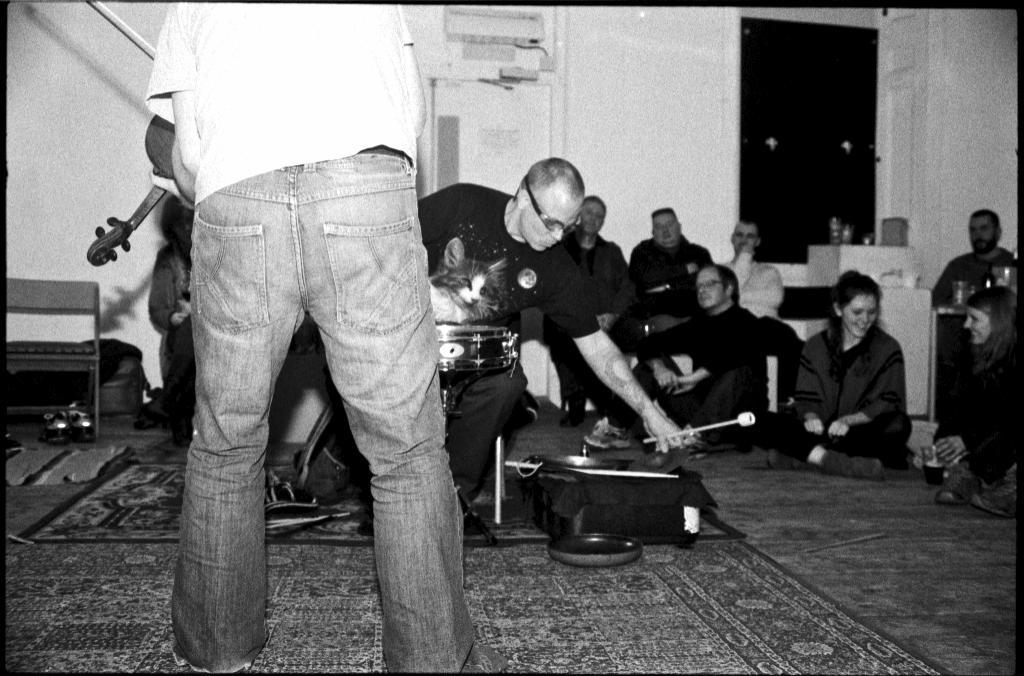What is the main subject of the image? There is a man standing in the image. What is the man holding in the image? There is another man holding a drum stick in the image. Are there any animals present in the image? Yes, there is a cat in the image. What are some people doing in the image? Some people are sitting on the floor in the image. What type of twig is the man using to play the drum in the image? There is no twig present in the image; the man is holding a drum stick. What letters are visible on the cat's collar in the image? There is no collar or letters visible on the cat in the image. 